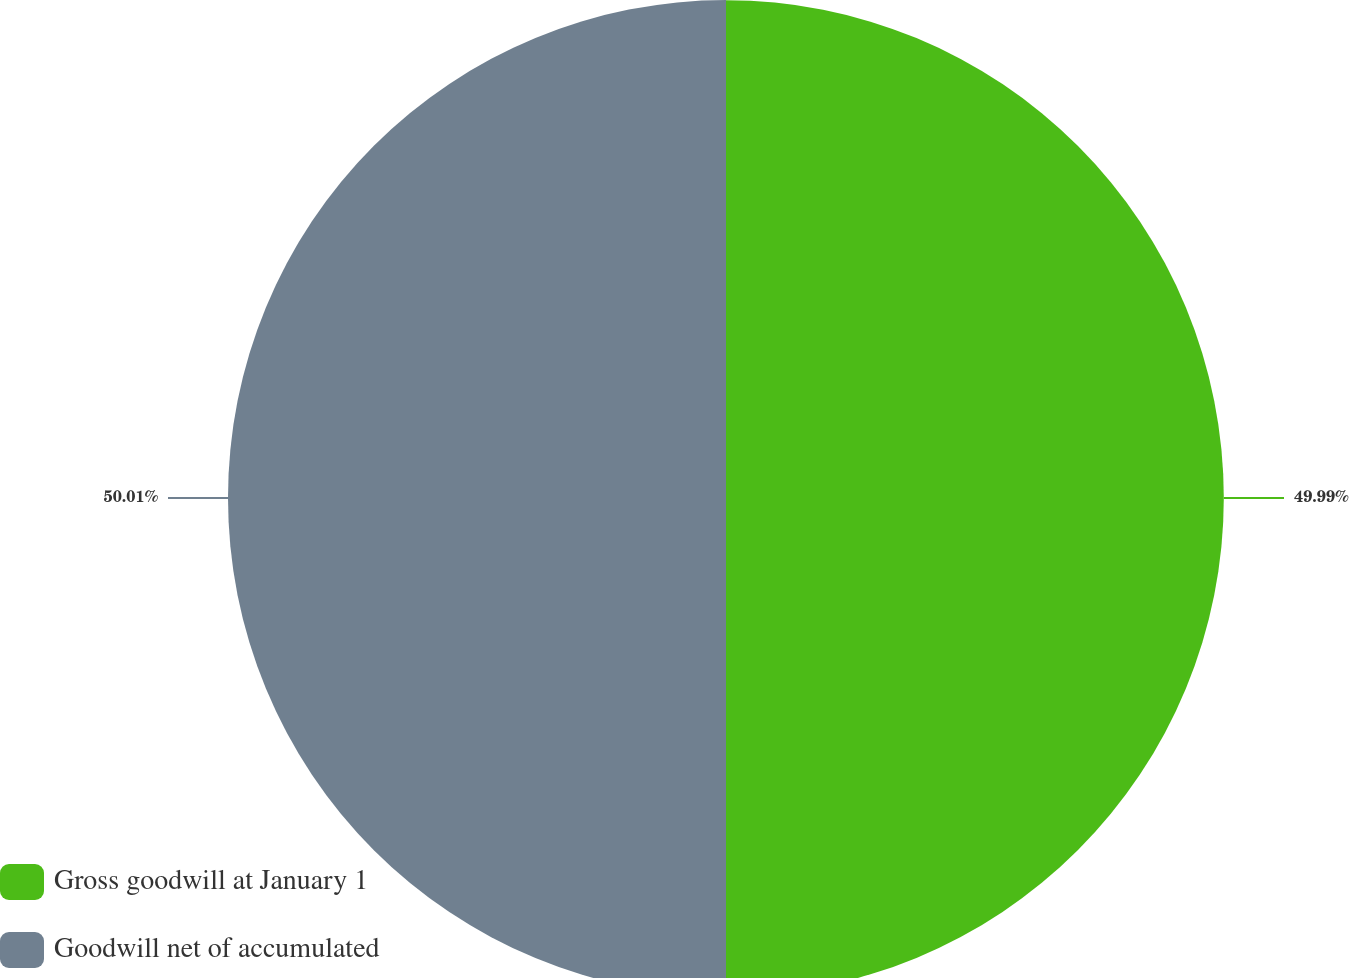<chart> <loc_0><loc_0><loc_500><loc_500><pie_chart><fcel>Gross goodwill at January 1<fcel>Goodwill net of accumulated<nl><fcel>49.99%<fcel>50.01%<nl></chart> 